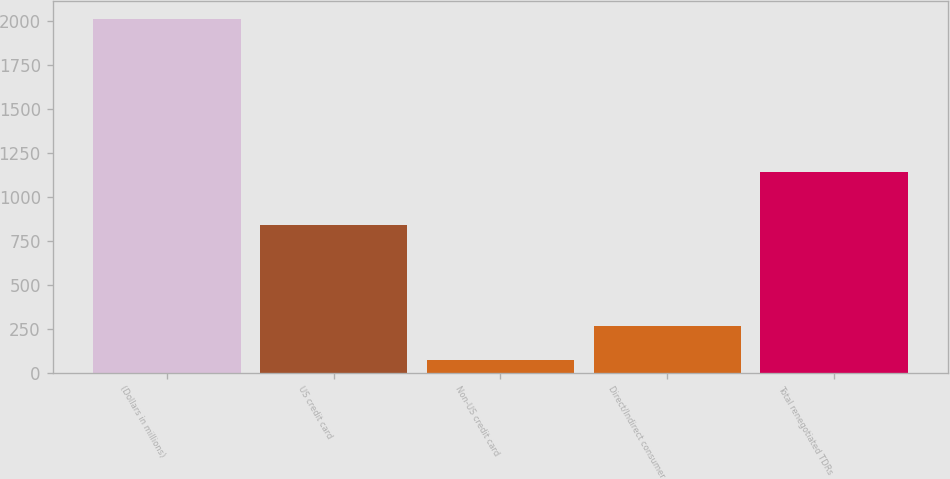<chart> <loc_0><loc_0><loc_500><loc_500><bar_chart><fcel>(Dollars in millions)<fcel>US credit card<fcel>Non-US credit card<fcel>Direct/Indirect consumer<fcel>Total renegotiated TDRs<nl><fcel>2013<fcel>842<fcel>71<fcel>265.2<fcel>1143<nl></chart> 